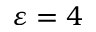Convert formula to latex. <formula><loc_0><loc_0><loc_500><loc_500>\varepsilon = 4</formula> 